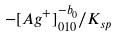<formula> <loc_0><loc_0><loc_500><loc_500>- [ A g ^ { + } ] _ { 0 1 0 } ^ { - b _ { 0 } } / K _ { s p }</formula> 